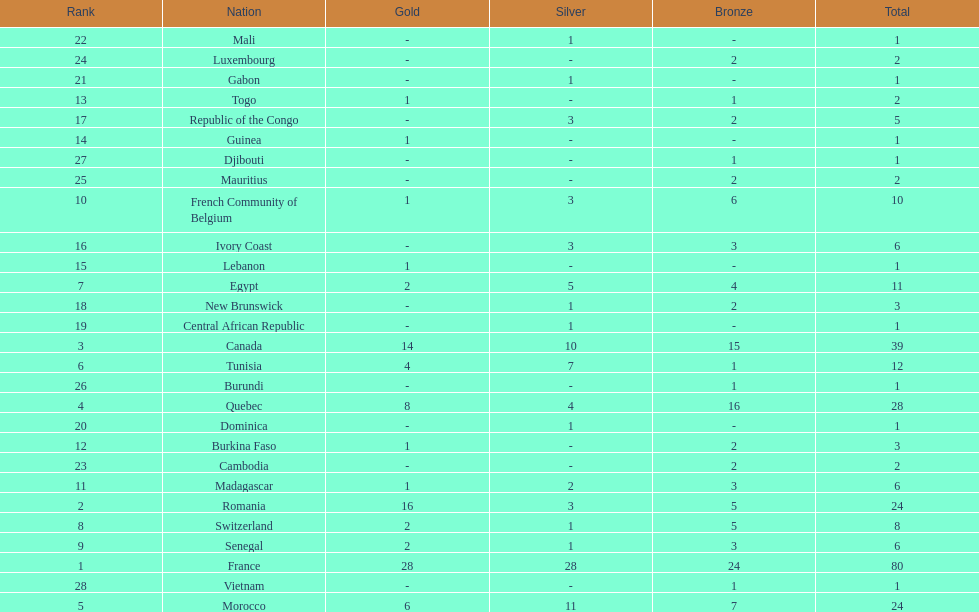How many nations won at least 10 medals? 8. 